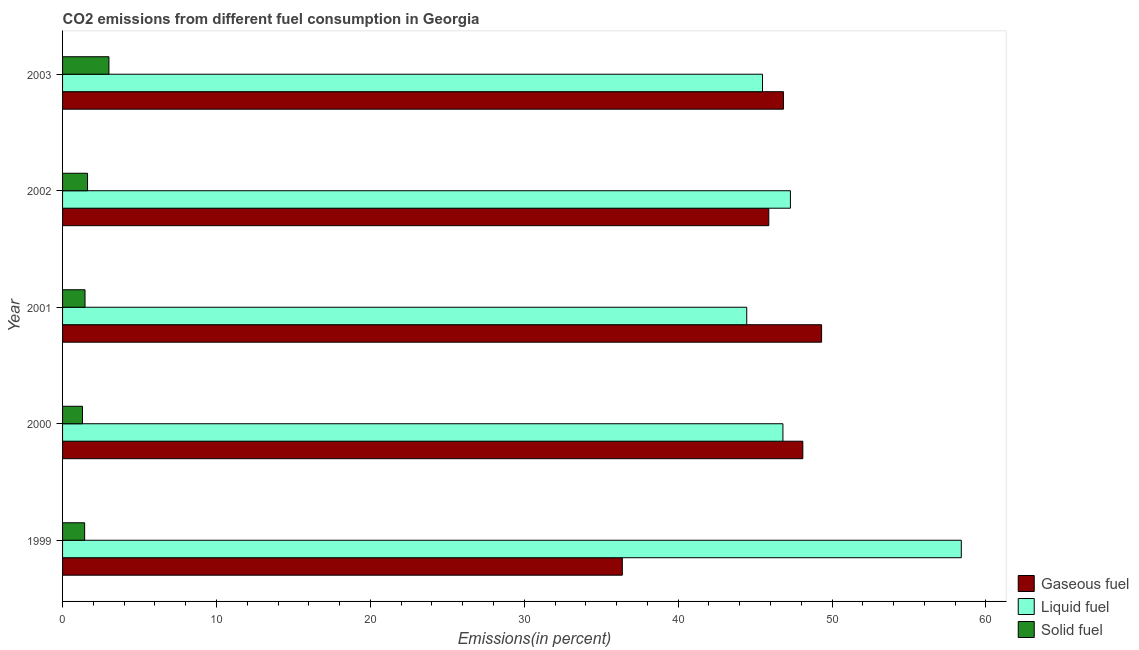How many bars are there on the 3rd tick from the bottom?
Give a very brief answer. 3. What is the label of the 3rd group of bars from the top?
Your answer should be compact. 2001. What is the percentage of liquid fuel emission in 1999?
Give a very brief answer. 58.4. Across all years, what is the maximum percentage of solid fuel emission?
Provide a short and direct response. 3.01. Across all years, what is the minimum percentage of liquid fuel emission?
Offer a very short reply. 44.46. What is the total percentage of liquid fuel emission in the graph?
Give a very brief answer. 242.43. What is the difference between the percentage of solid fuel emission in 2000 and that in 2003?
Offer a very short reply. -1.72. What is the difference between the percentage of solid fuel emission in 2000 and the percentage of gaseous fuel emission in 2003?
Keep it short and to the point. -45.55. What is the average percentage of liquid fuel emission per year?
Provide a succinct answer. 48.49. In the year 2002, what is the difference between the percentage of liquid fuel emission and percentage of solid fuel emission?
Offer a very short reply. 45.67. In how many years, is the percentage of gaseous fuel emission greater than 50 %?
Your response must be concise. 0. What is the ratio of the percentage of gaseous fuel emission in 2001 to that in 2002?
Keep it short and to the point. 1.07. Is the difference between the percentage of solid fuel emission in 1999 and 2003 greater than the difference between the percentage of gaseous fuel emission in 1999 and 2003?
Your answer should be very brief. Yes. What is the difference between the highest and the second highest percentage of liquid fuel emission?
Give a very brief answer. 11.1. What is the difference between the highest and the lowest percentage of solid fuel emission?
Your answer should be compact. 1.72. In how many years, is the percentage of solid fuel emission greater than the average percentage of solid fuel emission taken over all years?
Make the answer very short. 1. Is the sum of the percentage of gaseous fuel emission in 2001 and 2003 greater than the maximum percentage of solid fuel emission across all years?
Keep it short and to the point. Yes. What does the 2nd bar from the top in 2003 represents?
Ensure brevity in your answer.  Liquid fuel. What does the 3rd bar from the bottom in 2001 represents?
Give a very brief answer. Solid fuel. How many bars are there?
Provide a succinct answer. 15. Are all the bars in the graph horizontal?
Give a very brief answer. Yes. How many years are there in the graph?
Your response must be concise. 5. Does the graph contain any zero values?
Your answer should be very brief. No. Where does the legend appear in the graph?
Offer a terse response. Bottom right. How are the legend labels stacked?
Your answer should be very brief. Vertical. What is the title of the graph?
Offer a terse response. CO2 emissions from different fuel consumption in Georgia. Does "Taxes" appear as one of the legend labels in the graph?
Give a very brief answer. No. What is the label or title of the X-axis?
Provide a short and direct response. Emissions(in percent). What is the Emissions(in percent) of Gaseous fuel in 1999?
Give a very brief answer. 36.37. What is the Emissions(in percent) in Liquid fuel in 1999?
Provide a succinct answer. 58.4. What is the Emissions(in percent) in Solid fuel in 1999?
Keep it short and to the point. 1.43. What is the Emissions(in percent) in Gaseous fuel in 2000?
Keep it short and to the point. 48.1. What is the Emissions(in percent) of Liquid fuel in 2000?
Ensure brevity in your answer.  46.81. What is the Emissions(in percent) in Solid fuel in 2000?
Offer a very short reply. 1.29. What is the Emissions(in percent) in Gaseous fuel in 2001?
Provide a short and direct response. 49.32. What is the Emissions(in percent) in Liquid fuel in 2001?
Provide a succinct answer. 44.46. What is the Emissions(in percent) in Solid fuel in 2001?
Your answer should be very brief. 1.46. What is the Emissions(in percent) of Gaseous fuel in 2002?
Make the answer very short. 45.89. What is the Emissions(in percent) in Liquid fuel in 2002?
Keep it short and to the point. 47.29. What is the Emissions(in percent) of Solid fuel in 2002?
Provide a short and direct response. 1.62. What is the Emissions(in percent) in Gaseous fuel in 2003?
Give a very brief answer. 46.84. What is the Emissions(in percent) in Liquid fuel in 2003?
Keep it short and to the point. 45.48. What is the Emissions(in percent) in Solid fuel in 2003?
Your answer should be very brief. 3.01. Across all years, what is the maximum Emissions(in percent) of Gaseous fuel?
Your answer should be very brief. 49.32. Across all years, what is the maximum Emissions(in percent) in Liquid fuel?
Ensure brevity in your answer.  58.4. Across all years, what is the maximum Emissions(in percent) in Solid fuel?
Your answer should be compact. 3.01. Across all years, what is the minimum Emissions(in percent) of Gaseous fuel?
Provide a short and direct response. 36.37. Across all years, what is the minimum Emissions(in percent) of Liquid fuel?
Offer a terse response. 44.46. Across all years, what is the minimum Emissions(in percent) of Solid fuel?
Your response must be concise. 1.29. What is the total Emissions(in percent) of Gaseous fuel in the graph?
Your answer should be very brief. 226.52. What is the total Emissions(in percent) of Liquid fuel in the graph?
Your answer should be compact. 242.43. What is the total Emissions(in percent) of Solid fuel in the graph?
Keep it short and to the point. 8.82. What is the difference between the Emissions(in percent) of Gaseous fuel in 1999 and that in 2000?
Provide a succinct answer. -11.73. What is the difference between the Emissions(in percent) in Liquid fuel in 1999 and that in 2000?
Keep it short and to the point. 11.59. What is the difference between the Emissions(in percent) in Solid fuel in 1999 and that in 2000?
Your answer should be compact. 0.14. What is the difference between the Emissions(in percent) of Gaseous fuel in 1999 and that in 2001?
Ensure brevity in your answer.  -12.95. What is the difference between the Emissions(in percent) of Liquid fuel in 1999 and that in 2001?
Make the answer very short. 13.94. What is the difference between the Emissions(in percent) of Solid fuel in 1999 and that in 2001?
Give a very brief answer. -0.02. What is the difference between the Emissions(in percent) in Gaseous fuel in 1999 and that in 2002?
Your answer should be very brief. -9.52. What is the difference between the Emissions(in percent) of Liquid fuel in 1999 and that in 2002?
Ensure brevity in your answer.  11.1. What is the difference between the Emissions(in percent) of Solid fuel in 1999 and that in 2002?
Offer a terse response. -0.19. What is the difference between the Emissions(in percent) in Gaseous fuel in 1999 and that in 2003?
Provide a succinct answer. -10.47. What is the difference between the Emissions(in percent) of Liquid fuel in 1999 and that in 2003?
Offer a very short reply. 12.92. What is the difference between the Emissions(in percent) of Solid fuel in 1999 and that in 2003?
Ensure brevity in your answer.  -1.58. What is the difference between the Emissions(in percent) of Gaseous fuel in 2000 and that in 2001?
Provide a short and direct response. -1.22. What is the difference between the Emissions(in percent) in Liquid fuel in 2000 and that in 2001?
Your answer should be very brief. 2.35. What is the difference between the Emissions(in percent) in Solid fuel in 2000 and that in 2001?
Your answer should be very brief. -0.17. What is the difference between the Emissions(in percent) in Gaseous fuel in 2000 and that in 2002?
Make the answer very short. 2.21. What is the difference between the Emissions(in percent) of Liquid fuel in 2000 and that in 2002?
Give a very brief answer. -0.49. What is the difference between the Emissions(in percent) in Solid fuel in 2000 and that in 2002?
Your answer should be compact. -0.33. What is the difference between the Emissions(in percent) in Gaseous fuel in 2000 and that in 2003?
Your response must be concise. 1.26. What is the difference between the Emissions(in percent) in Liquid fuel in 2000 and that in 2003?
Your response must be concise. 1.33. What is the difference between the Emissions(in percent) of Solid fuel in 2000 and that in 2003?
Offer a terse response. -1.72. What is the difference between the Emissions(in percent) in Gaseous fuel in 2001 and that in 2002?
Give a very brief answer. 3.43. What is the difference between the Emissions(in percent) in Liquid fuel in 2001 and that in 2002?
Provide a succinct answer. -2.84. What is the difference between the Emissions(in percent) of Solid fuel in 2001 and that in 2002?
Make the answer very short. -0.16. What is the difference between the Emissions(in percent) of Gaseous fuel in 2001 and that in 2003?
Offer a terse response. 2.48. What is the difference between the Emissions(in percent) of Liquid fuel in 2001 and that in 2003?
Give a very brief answer. -1.03. What is the difference between the Emissions(in percent) of Solid fuel in 2001 and that in 2003?
Provide a succinct answer. -1.55. What is the difference between the Emissions(in percent) in Gaseous fuel in 2002 and that in 2003?
Provide a succinct answer. -0.95. What is the difference between the Emissions(in percent) of Liquid fuel in 2002 and that in 2003?
Your answer should be compact. 1.81. What is the difference between the Emissions(in percent) of Solid fuel in 2002 and that in 2003?
Provide a succinct answer. -1.39. What is the difference between the Emissions(in percent) in Gaseous fuel in 1999 and the Emissions(in percent) in Liquid fuel in 2000?
Your answer should be very brief. -10.44. What is the difference between the Emissions(in percent) of Gaseous fuel in 1999 and the Emissions(in percent) of Solid fuel in 2000?
Make the answer very short. 35.08. What is the difference between the Emissions(in percent) of Liquid fuel in 1999 and the Emissions(in percent) of Solid fuel in 2000?
Your response must be concise. 57.1. What is the difference between the Emissions(in percent) in Gaseous fuel in 1999 and the Emissions(in percent) in Liquid fuel in 2001?
Keep it short and to the point. -8.08. What is the difference between the Emissions(in percent) in Gaseous fuel in 1999 and the Emissions(in percent) in Solid fuel in 2001?
Your answer should be compact. 34.91. What is the difference between the Emissions(in percent) of Liquid fuel in 1999 and the Emissions(in percent) of Solid fuel in 2001?
Your response must be concise. 56.94. What is the difference between the Emissions(in percent) in Gaseous fuel in 1999 and the Emissions(in percent) in Liquid fuel in 2002?
Provide a short and direct response. -10.92. What is the difference between the Emissions(in percent) in Gaseous fuel in 1999 and the Emissions(in percent) in Solid fuel in 2002?
Your answer should be very brief. 34.75. What is the difference between the Emissions(in percent) in Liquid fuel in 1999 and the Emissions(in percent) in Solid fuel in 2002?
Keep it short and to the point. 56.77. What is the difference between the Emissions(in percent) in Gaseous fuel in 1999 and the Emissions(in percent) in Liquid fuel in 2003?
Your response must be concise. -9.11. What is the difference between the Emissions(in percent) of Gaseous fuel in 1999 and the Emissions(in percent) of Solid fuel in 2003?
Your answer should be very brief. 33.36. What is the difference between the Emissions(in percent) in Liquid fuel in 1999 and the Emissions(in percent) in Solid fuel in 2003?
Provide a short and direct response. 55.38. What is the difference between the Emissions(in percent) in Gaseous fuel in 2000 and the Emissions(in percent) in Liquid fuel in 2001?
Provide a short and direct response. 3.65. What is the difference between the Emissions(in percent) of Gaseous fuel in 2000 and the Emissions(in percent) of Solid fuel in 2001?
Give a very brief answer. 46.64. What is the difference between the Emissions(in percent) of Liquid fuel in 2000 and the Emissions(in percent) of Solid fuel in 2001?
Offer a very short reply. 45.35. What is the difference between the Emissions(in percent) of Gaseous fuel in 2000 and the Emissions(in percent) of Liquid fuel in 2002?
Ensure brevity in your answer.  0.81. What is the difference between the Emissions(in percent) of Gaseous fuel in 2000 and the Emissions(in percent) of Solid fuel in 2002?
Give a very brief answer. 46.48. What is the difference between the Emissions(in percent) in Liquid fuel in 2000 and the Emissions(in percent) in Solid fuel in 2002?
Offer a terse response. 45.18. What is the difference between the Emissions(in percent) in Gaseous fuel in 2000 and the Emissions(in percent) in Liquid fuel in 2003?
Your response must be concise. 2.62. What is the difference between the Emissions(in percent) in Gaseous fuel in 2000 and the Emissions(in percent) in Solid fuel in 2003?
Give a very brief answer. 45.09. What is the difference between the Emissions(in percent) of Liquid fuel in 2000 and the Emissions(in percent) of Solid fuel in 2003?
Offer a very short reply. 43.79. What is the difference between the Emissions(in percent) of Gaseous fuel in 2001 and the Emissions(in percent) of Liquid fuel in 2002?
Make the answer very short. 2.02. What is the difference between the Emissions(in percent) in Gaseous fuel in 2001 and the Emissions(in percent) in Solid fuel in 2002?
Your answer should be compact. 47.7. What is the difference between the Emissions(in percent) of Liquid fuel in 2001 and the Emissions(in percent) of Solid fuel in 2002?
Keep it short and to the point. 42.83. What is the difference between the Emissions(in percent) in Gaseous fuel in 2001 and the Emissions(in percent) in Liquid fuel in 2003?
Ensure brevity in your answer.  3.84. What is the difference between the Emissions(in percent) in Gaseous fuel in 2001 and the Emissions(in percent) in Solid fuel in 2003?
Offer a terse response. 46.31. What is the difference between the Emissions(in percent) of Liquid fuel in 2001 and the Emissions(in percent) of Solid fuel in 2003?
Provide a short and direct response. 41.44. What is the difference between the Emissions(in percent) in Gaseous fuel in 2002 and the Emissions(in percent) in Liquid fuel in 2003?
Keep it short and to the point. 0.41. What is the difference between the Emissions(in percent) in Gaseous fuel in 2002 and the Emissions(in percent) in Solid fuel in 2003?
Your response must be concise. 42.87. What is the difference between the Emissions(in percent) in Liquid fuel in 2002 and the Emissions(in percent) in Solid fuel in 2003?
Keep it short and to the point. 44.28. What is the average Emissions(in percent) of Gaseous fuel per year?
Your response must be concise. 45.3. What is the average Emissions(in percent) in Liquid fuel per year?
Offer a very short reply. 48.49. What is the average Emissions(in percent) of Solid fuel per year?
Provide a short and direct response. 1.76. In the year 1999, what is the difference between the Emissions(in percent) of Gaseous fuel and Emissions(in percent) of Liquid fuel?
Make the answer very short. -22.03. In the year 1999, what is the difference between the Emissions(in percent) of Gaseous fuel and Emissions(in percent) of Solid fuel?
Provide a succinct answer. 34.94. In the year 1999, what is the difference between the Emissions(in percent) in Liquid fuel and Emissions(in percent) in Solid fuel?
Provide a short and direct response. 56.96. In the year 2000, what is the difference between the Emissions(in percent) of Gaseous fuel and Emissions(in percent) of Liquid fuel?
Your answer should be very brief. 1.29. In the year 2000, what is the difference between the Emissions(in percent) in Gaseous fuel and Emissions(in percent) in Solid fuel?
Provide a short and direct response. 46.81. In the year 2000, what is the difference between the Emissions(in percent) of Liquid fuel and Emissions(in percent) of Solid fuel?
Your answer should be very brief. 45.51. In the year 2001, what is the difference between the Emissions(in percent) in Gaseous fuel and Emissions(in percent) in Liquid fuel?
Offer a terse response. 4.86. In the year 2001, what is the difference between the Emissions(in percent) in Gaseous fuel and Emissions(in percent) in Solid fuel?
Offer a terse response. 47.86. In the year 2001, what is the difference between the Emissions(in percent) in Liquid fuel and Emissions(in percent) in Solid fuel?
Your answer should be very brief. 43. In the year 2002, what is the difference between the Emissions(in percent) of Gaseous fuel and Emissions(in percent) of Liquid fuel?
Make the answer very short. -1.41. In the year 2002, what is the difference between the Emissions(in percent) in Gaseous fuel and Emissions(in percent) in Solid fuel?
Your answer should be compact. 44.26. In the year 2002, what is the difference between the Emissions(in percent) of Liquid fuel and Emissions(in percent) of Solid fuel?
Ensure brevity in your answer.  45.67. In the year 2003, what is the difference between the Emissions(in percent) in Gaseous fuel and Emissions(in percent) in Liquid fuel?
Give a very brief answer. 1.36. In the year 2003, what is the difference between the Emissions(in percent) in Gaseous fuel and Emissions(in percent) in Solid fuel?
Ensure brevity in your answer.  43.83. In the year 2003, what is the difference between the Emissions(in percent) in Liquid fuel and Emissions(in percent) in Solid fuel?
Offer a very short reply. 42.47. What is the ratio of the Emissions(in percent) in Gaseous fuel in 1999 to that in 2000?
Your answer should be compact. 0.76. What is the ratio of the Emissions(in percent) in Liquid fuel in 1999 to that in 2000?
Provide a succinct answer. 1.25. What is the ratio of the Emissions(in percent) in Solid fuel in 1999 to that in 2000?
Provide a succinct answer. 1.11. What is the ratio of the Emissions(in percent) of Gaseous fuel in 1999 to that in 2001?
Give a very brief answer. 0.74. What is the ratio of the Emissions(in percent) of Liquid fuel in 1999 to that in 2001?
Give a very brief answer. 1.31. What is the ratio of the Emissions(in percent) in Solid fuel in 1999 to that in 2001?
Keep it short and to the point. 0.98. What is the ratio of the Emissions(in percent) in Gaseous fuel in 1999 to that in 2002?
Provide a succinct answer. 0.79. What is the ratio of the Emissions(in percent) in Liquid fuel in 1999 to that in 2002?
Your answer should be very brief. 1.23. What is the ratio of the Emissions(in percent) in Solid fuel in 1999 to that in 2002?
Provide a short and direct response. 0.88. What is the ratio of the Emissions(in percent) in Gaseous fuel in 1999 to that in 2003?
Ensure brevity in your answer.  0.78. What is the ratio of the Emissions(in percent) of Liquid fuel in 1999 to that in 2003?
Give a very brief answer. 1.28. What is the ratio of the Emissions(in percent) in Solid fuel in 1999 to that in 2003?
Your answer should be compact. 0.48. What is the ratio of the Emissions(in percent) in Gaseous fuel in 2000 to that in 2001?
Provide a short and direct response. 0.98. What is the ratio of the Emissions(in percent) of Liquid fuel in 2000 to that in 2001?
Give a very brief answer. 1.05. What is the ratio of the Emissions(in percent) of Solid fuel in 2000 to that in 2001?
Make the answer very short. 0.89. What is the ratio of the Emissions(in percent) in Gaseous fuel in 2000 to that in 2002?
Give a very brief answer. 1.05. What is the ratio of the Emissions(in percent) in Solid fuel in 2000 to that in 2002?
Your answer should be very brief. 0.8. What is the ratio of the Emissions(in percent) in Gaseous fuel in 2000 to that in 2003?
Your answer should be compact. 1.03. What is the ratio of the Emissions(in percent) in Liquid fuel in 2000 to that in 2003?
Offer a very short reply. 1.03. What is the ratio of the Emissions(in percent) of Solid fuel in 2000 to that in 2003?
Your response must be concise. 0.43. What is the ratio of the Emissions(in percent) of Gaseous fuel in 2001 to that in 2002?
Make the answer very short. 1.07. What is the ratio of the Emissions(in percent) in Solid fuel in 2001 to that in 2002?
Provide a succinct answer. 0.9. What is the ratio of the Emissions(in percent) in Gaseous fuel in 2001 to that in 2003?
Offer a terse response. 1.05. What is the ratio of the Emissions(in percent) in Liquid fuel in 2001 to that in 2003?
Your response must be concise. 0.98. What is the ratio of the Emissions(in percent) of Solid fuel in 2001 to that in 2003?
Your answer should be compact. 0.48. What is the ratio of the Emissions(in percent) in Gaseous fuel in 2002 to that in 2003?
Give a very brief answer. 0.98. What is the ratio of the Emissions(in percent) of Liquid fuel in 2002 to that in 2003?
Provide a short and direct response. 1.04. What is the ratio of the Emissions(in percent) of Solid fuel in 2002 to that in 2003?
Ensure brevity in your answer.  0.54. What is the difference between the highest and the second highest Emissions(in percent) of Gaseous fuel?
Your response must be concise. 1.22. What is the difference between the highest and the second highest Emissions(in percent) in Liquid fuel?
Your response must be concise. 11.1. What is the difference between the highest and the second highest Emissions(in percent) in Solid fuel?
Ensure brevity in your answer.  1.39. What is the difference between the highest and the lowest Emissions(in percent) of Gaseous fuel?
Give a very brief answer. 12.95. What is the difference between the highest and the lowest Emissions(in percent) in Liquid fuel?
Provide a short and direct response. 13.94. What is the difference between the highest and the lowest Emissions(in percent) in Solid fuel?
Make the answer very short. 1.72. 